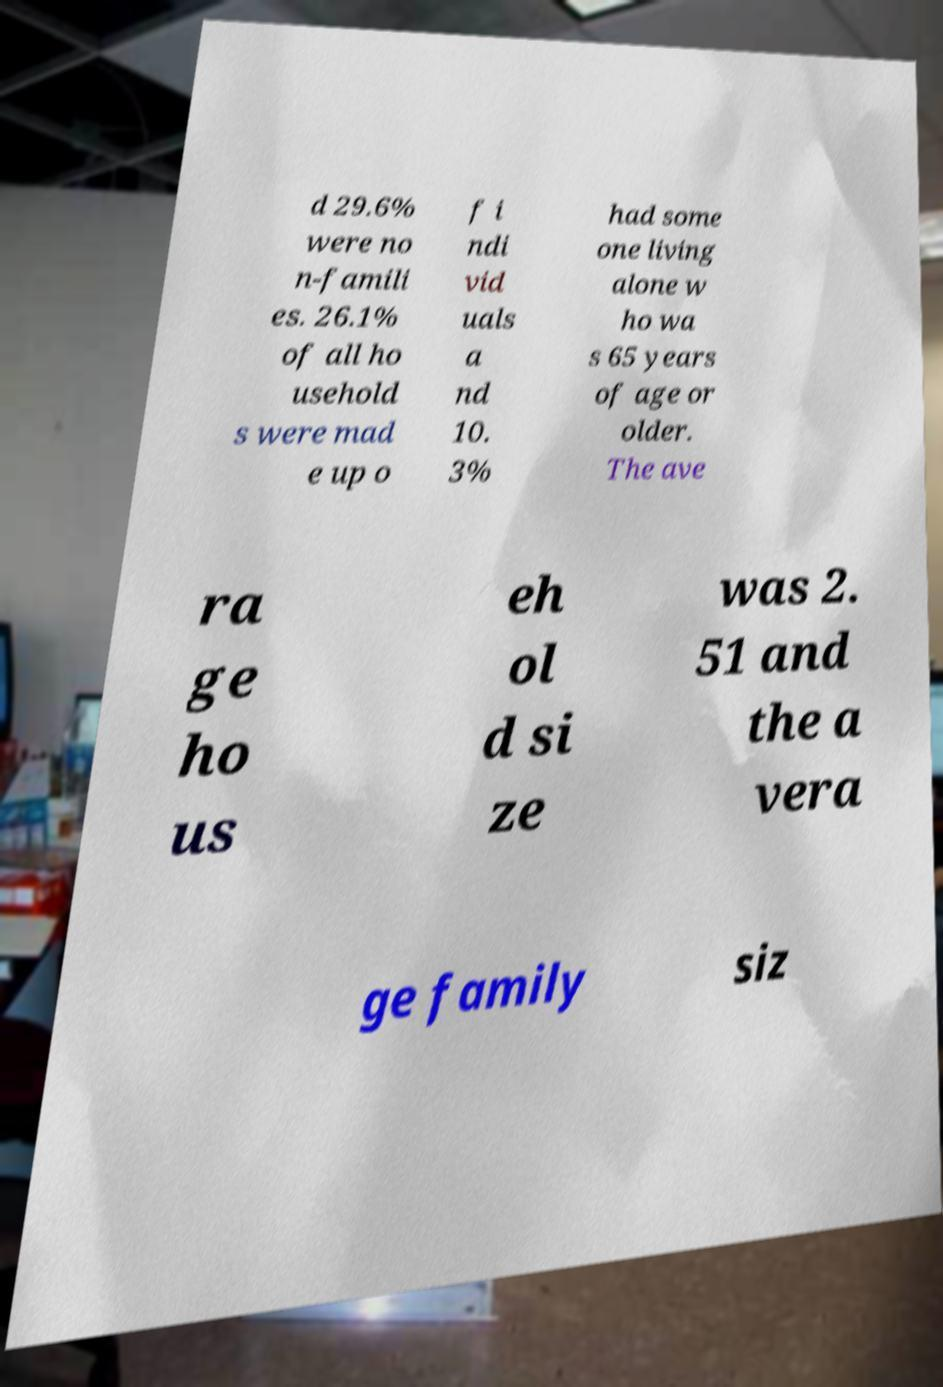Please read and relay the text visible in this image. What does it say? d 29.6% were no n-famili es. 26.1% of all ho usehold s were mad e up o f i ndi vid uals a nd 10. 3% had some one living alone w ho wa s 65 years of age or older. The ave ra ge ho us eh ol d si ze was 2. 51 and the a vera ge family siz 